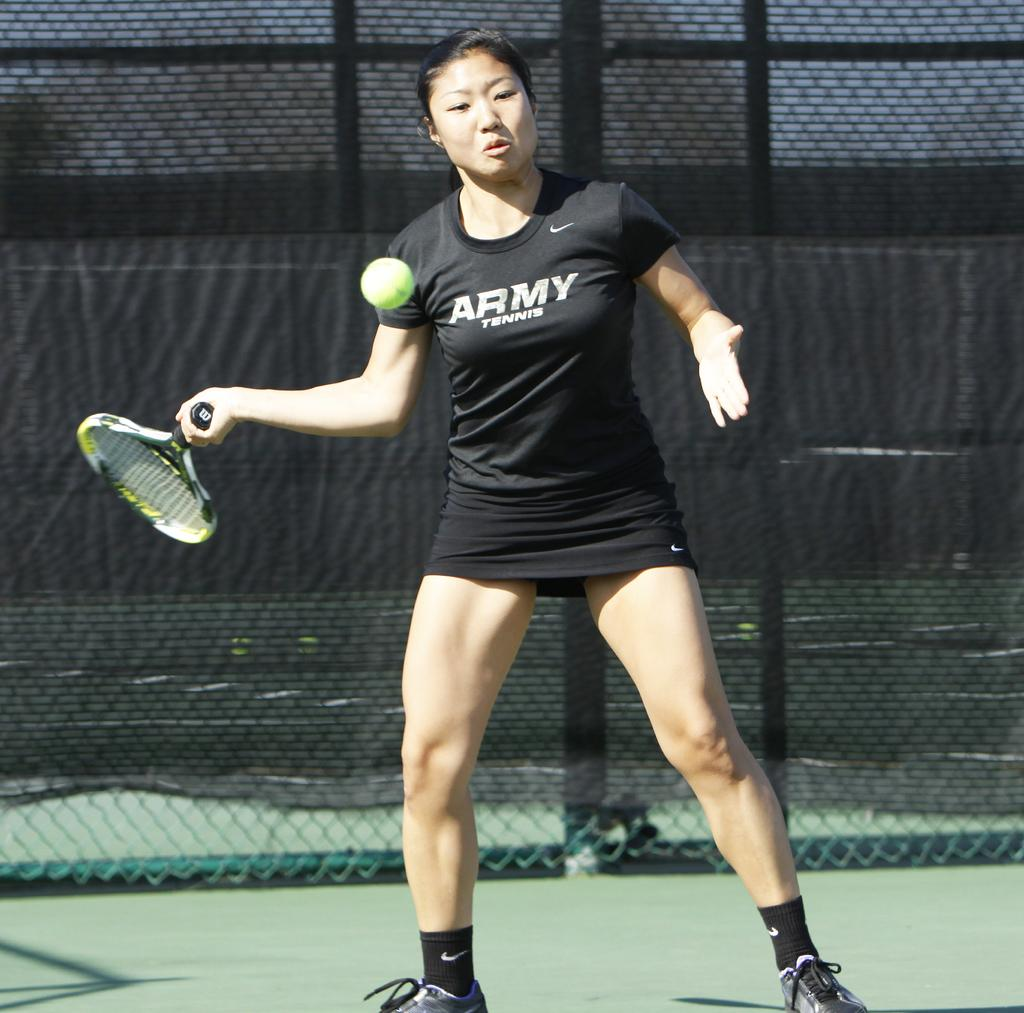Who is present in the image? There is a woman in the image. What is the woman wearing? The woman is wearing a black dress. What is the woman holding in the image? The woman is holding a tennis racket. What is the woman trying to do with the tennis racket? The woman is trying to hit a ball. What can be seen in the background of the image? There is a fencing behind the woman. How deep is the hole that the woman is standing in the image? There is no hole present in the image; the woman is standing on a surface, not in a hole. 